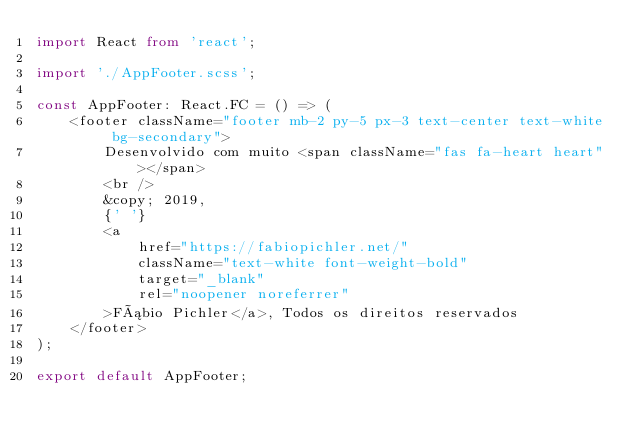<code> <loc_0><loc_0><loc_500><loc_500><_TypeScript_>import React from 'react';

import './AppFooter.scss';

const AppFooter: React.FC = () => (
    <footer className="footer mb-2 py-5 px-3 text-center text-white bg-secondary">
        Desenvolvido com muito <span className="fas fa-heart heart"></span>
        <br />
        &copy; 2019,
        {' '}
        <a
            href="https://fabiopichler.net/"
            className="text-white font-weight-bold"
            target="_blank"
            rel="noopener noreferrer"
        >Fábio Pichler</a>, Todos os direitos reservados
    </footer>
);

export default AppFooter;
</code> 